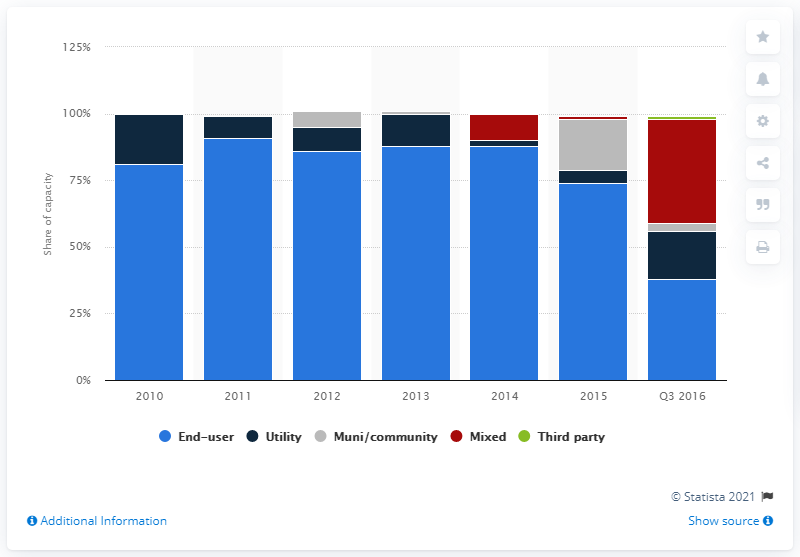Indicate a few pertinent items in this graphic. In 2010, utility microgrid capacity accounted for by utility end-users made up approximately 19% of the total capacity. 